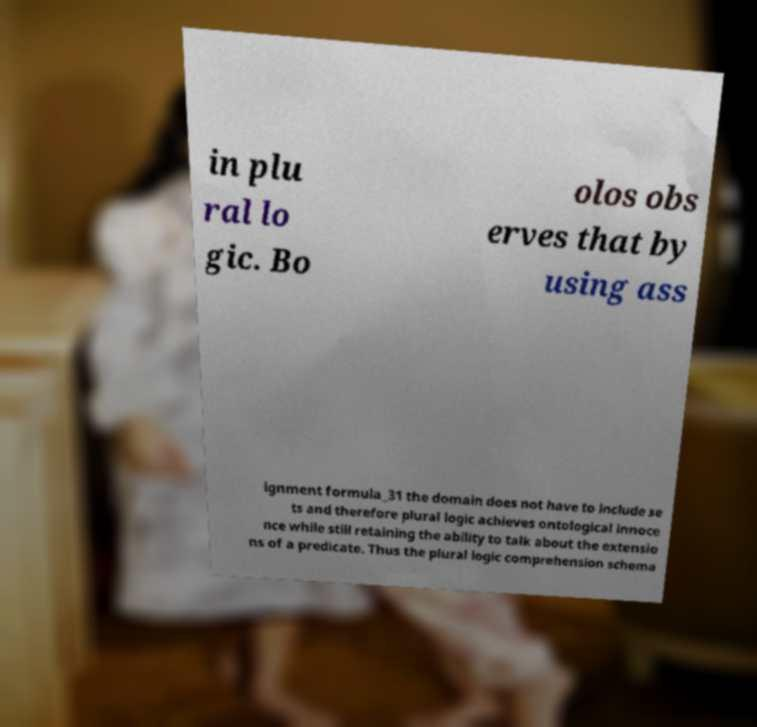Can you read and provide the text displayed in the image?This photo seems to have some interesting text. Can you extract and type it out for me? in plu ral lo gic. Bo olos obs erves that by using ass ignment formula_31 the domain does not have to include se ts and therefore plural logic achieves ontological innoce nce while still retaining the ability to talk about the extensio ns of a predicate. Thus the plural logic comprehension schema 